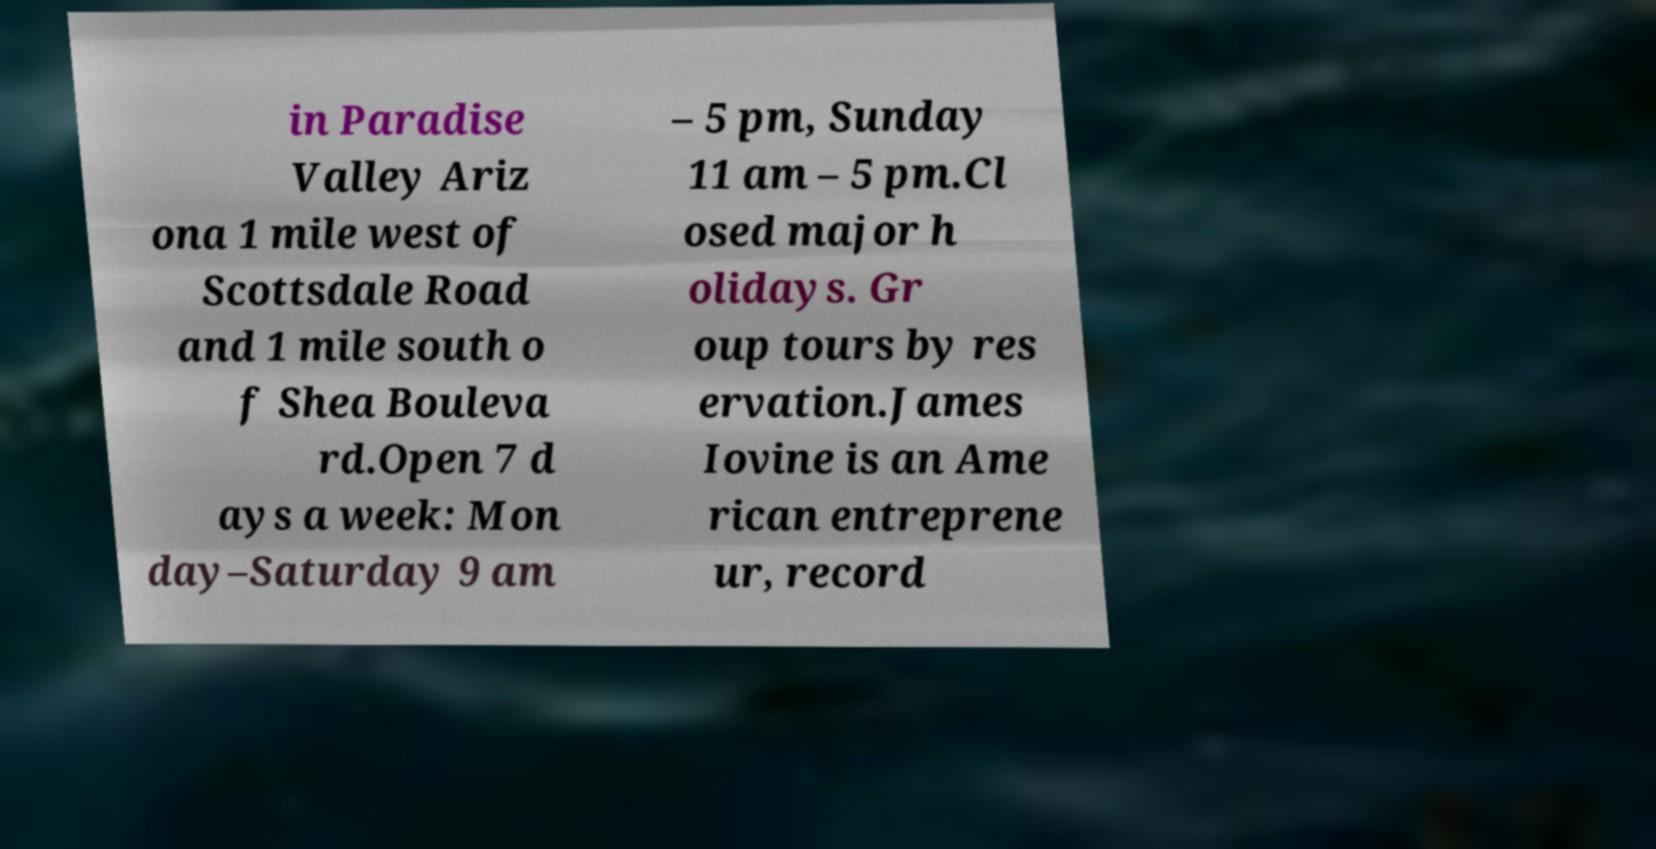There's text embedded in this image that I need extracted. Can you transcribe it verbatim? in Paradise Valley Ariz ona 1 mile west of Scottsdale Road and 1 mile south o f Shea Bouleva rd.Open 7 d ays a week: Mon day–Saturday 9 am – 5 pm, Sunday 11 am – 5 pm.Cl osed major h olidays. Gr oup tours by res ervation.James Iovine is an Ame rican entreprene ur, record 